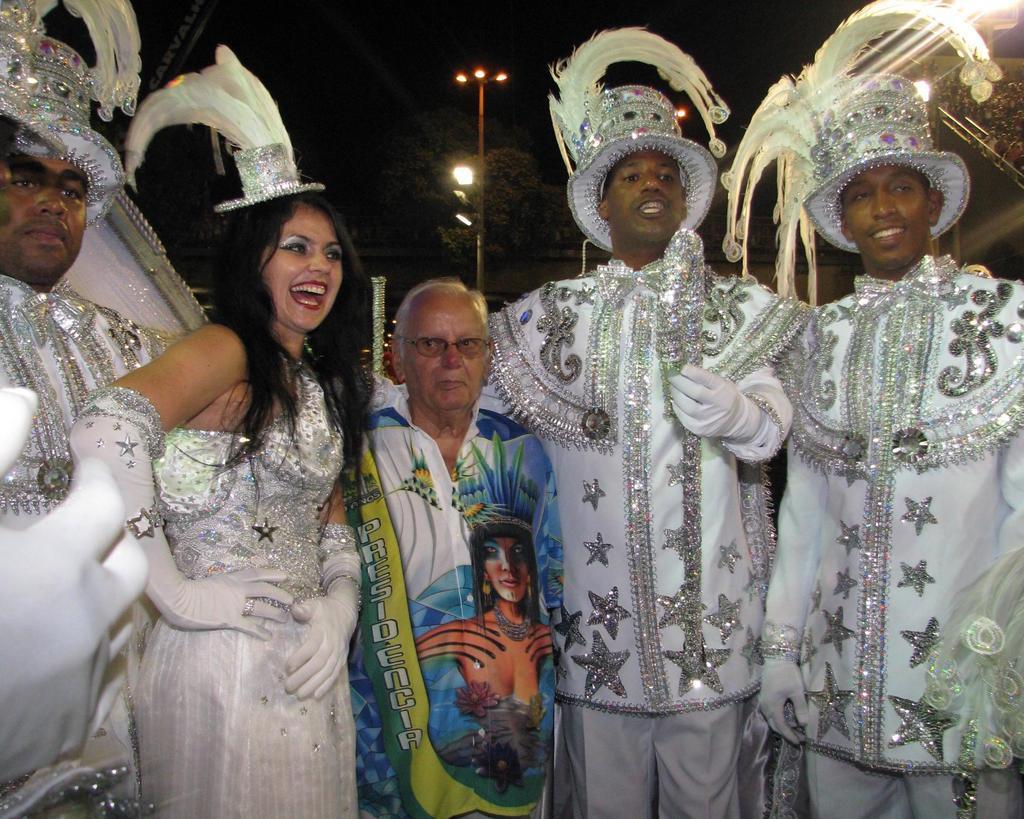Could you give a brief overview of what you see in this image? In this image we can see people in a costume and behind them, we can see light poles and trees. 